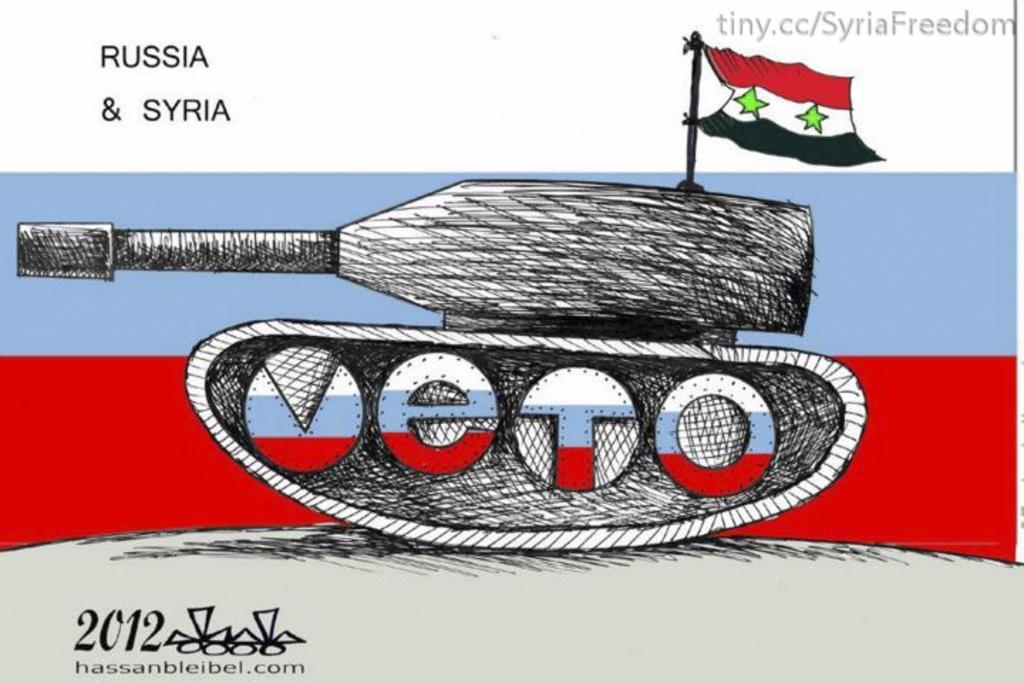Describe this image in one or two sentences. In this picture we can see a white color object seems to be the poster on which we can see the text, numbers and the picture of a tank and a picture of a flag and some other pictures. 